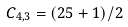<formula> <loc_0><loc_0><loc_500><loc_500>C _ { 4 , 3 } = ( 2 5 + 1 ) / 2</formula> 